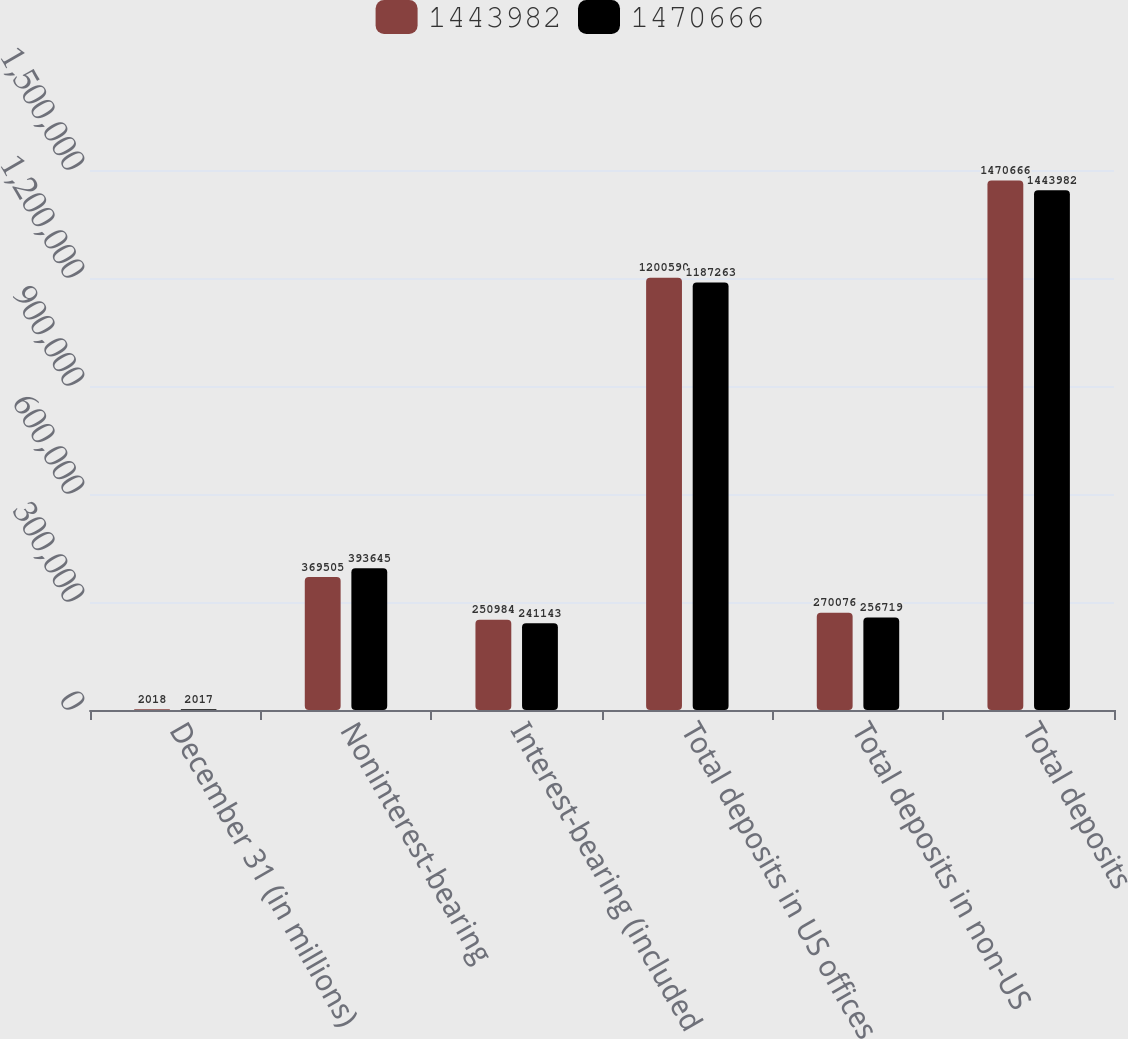Convert chart. <chart><loc_0><loc_0><loc_500><loc_500><stacked_bar_chart><ecel><fcel>December 31 (in millions)<fcel>Noninterest-bearing<fcel>Interest-bearing (included<fcel>Total deposits in US offices<fcel>Total deposits in non-US<fcel>Total deposits<nl><fcel>1.44398e+06<fcel>2018<fcel>369505<fcel>250984<fcel>1.20059e+06<fcel>270076<fcel>1.47067e+06<nl><fcel>1.47067e+06<fcel>2017<fcel>393645<fcel>241143<fcel>1.18726e+06<fcel>256719<fcel>1.44398e+06<nl></chart> 